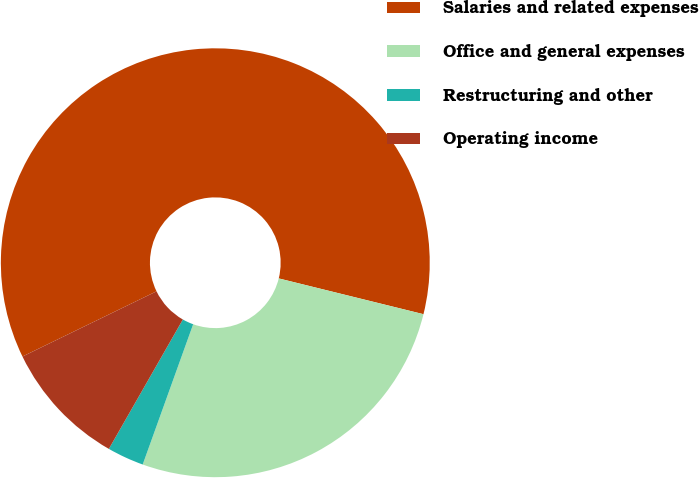Convert chart to OTSL. <chart><loc_0><loc_0><loc_500><loc_500><pie_chart><fcel>Salaries and related expenses<fcel>Office and general expenses<fcel>Restructuring and other<fcel>Operating income<nl><fcel>61.06%<fcel>26.64%<fcel>2.77%<fcel>9.53%<nl></chart> 